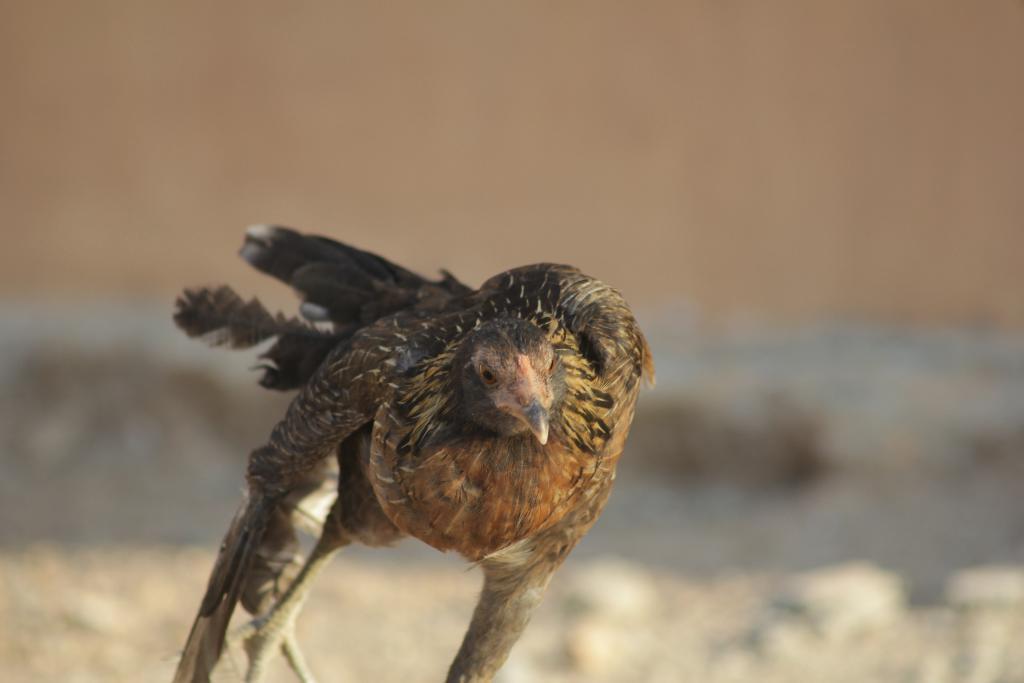Could you give a brief overview of what you see in this image? In this image we can see a bird. On the backside we can see a wall. 